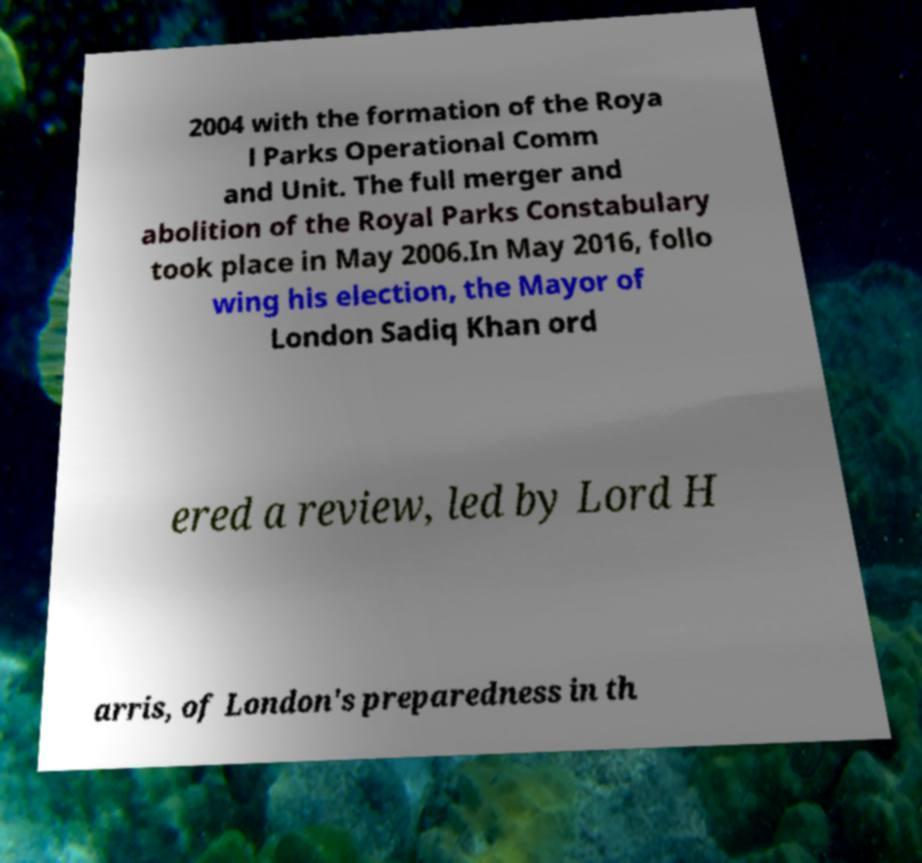Please identify and transcribe the text found in this image. 2004 with the formation of the Roya l Parks Operational Comm and Unit. The full merger and abolition of the Royal Parks Constabulary took place in May 2006.In May 2016, follo wing his election, the Mayor of London Sadiq Khan ord ered a review, led by Lord H arris, of London's preparedness in th 